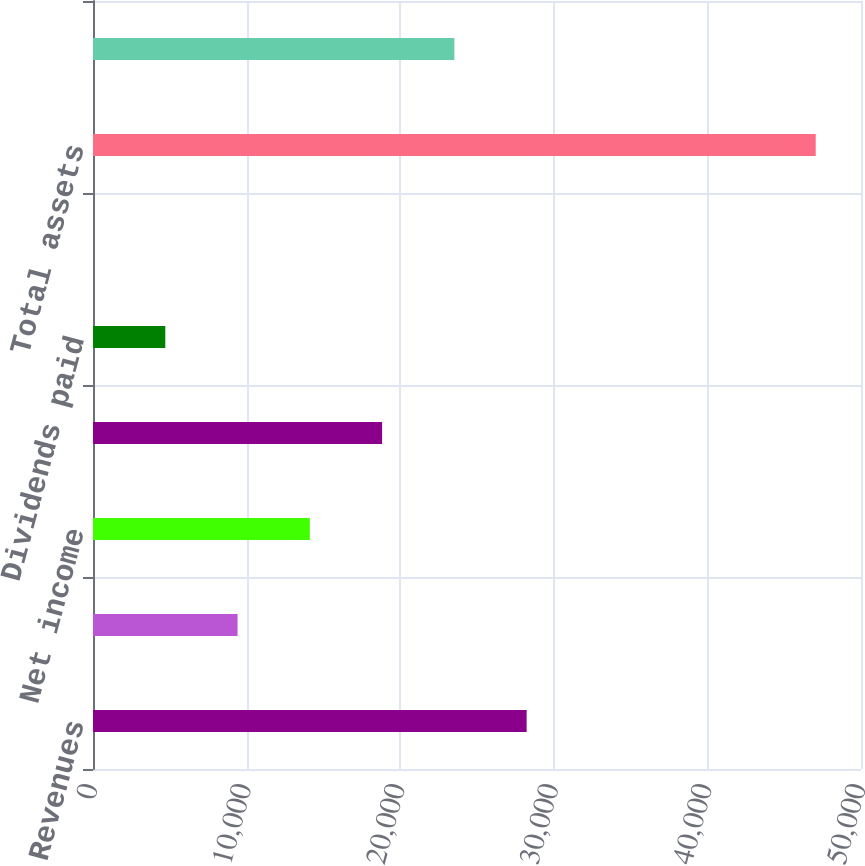<chart> <loc_0><loc_0><loc_500><loc_500><bar_chart><fcel>Revenues<fcel>Income from continuing<fcel>Net income<fcel>Additions to property plant<fcel>Dividends paid<fcel>Dividends per share<fcel>Total assets<fcel>Total long-term debt including<nl><fcel>28231.6<fcel>9411.16<fcel>14116.3<fcel>18821.4<fcel>4706.06<fcel>0.96<fcel>47052<fcel>23526.5<nl></chart> 